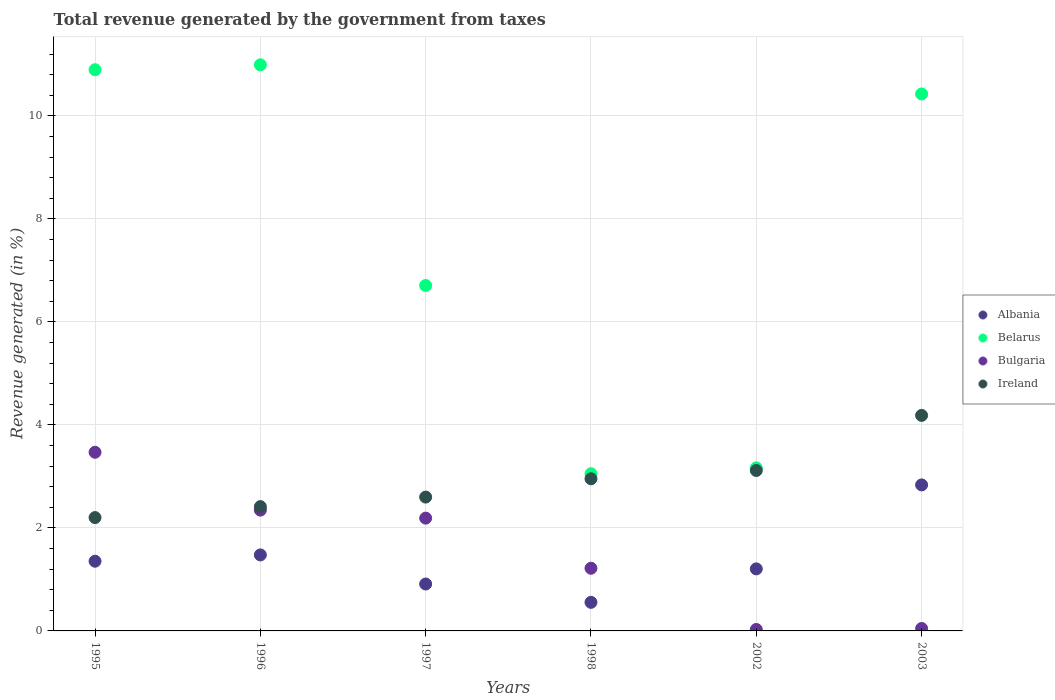Is the number of dotlines equal to the number of legend labels?
Keep it short and to the point. Yes. What is the total revenue generated in Bulgaria in 1996?
Your answer should be very brief. 2.35. Across all years, what is the maximum total revenue generated in Ireland?
Provide a succinct answer. 4.18. Across all years, what is the minimum total revenue generated in Belarus?
Ensure brevity in your answer.  3.05. What is the total total revenue generated in Ireland in the graph?
Your answer should be very brief. 17.47. What is the difference between the total revenue generated in Bulgaria in 1996 and that in 1998?
Provide a short and direct response. 1.13. What is the difference between the total revenue generated in Ireland in 2003 and the total revenue generated in Bulgaria in 1995?
Your answer should be compact. 0.72. What is the average total revenue generated in Ireland per year?
Offer a very short reply. 2.91. In the year 2002, what is the difference between the total revenue generated in Ireland and total revenue generated in Belarus?
Provide a short and direct response. -0.05. What is the ratio of the total revenue generated in Bulgaria in 1996 to that in 1998?
Give a very brief answer. 1.93. Is the total revenue generated in Belarus in 1996 less than that in 1997?
Your response must be concise. No. Is the difference between the total revenue generated in Ireland in 1997 and 2003 greater than the difference between the total revenue generated in Belarus in 1997 and 2003?
Ensure brevity in your answer.  Yes. What is the difference between the highest and the second highest total revenue generated in Ireland?
Your response must be concise. 1.07. What is the difference between the highest and the lowest total revenue generated in Belarus?
Provide a short and direct response. 7.94. Is the sum of the total revenue generated in Albania in 1998 and 2003 greater than the maximum total revenue generated in Ireland across all years?
Give a very brief answer. No. Is it the case that in every year, the sum of the total revenue generated in Albania and total revenue generated in Ireland  is greater than the sum of total revenue generated in Belarus and total revenue generated in Bulgaria?
Provide a short and direct response. No. Is it the case that in every year, the sum of the total revenue generated in Belarus and total revenue generated in Ireland  is greater than the total revenue generated in Bulgaria?
Your response must be concise. Yes. Does the total revenue generated in Albania monotonically increase over the years?
Offer a terse response. No. Is the total revenue generated in Bulgaria strictly greater than the total revenue generated in Ireland over the years?
Offer a terse response. No. Does the graph contain any zero values?
Offer a very short reply. No. Does the graph contain grids?
Your response must be concise. Yes. Where does the legend appear in the graph?
Provide a short and direct response. Center right. What is the title of the graph?
Give a very brief answer. Total revenue generated by the government from taxes. Does "Middle East & North Africa (all income levels)" appear as one of the legend labels in the graph?
Give a very brief answer. No. What is the label or title of the X-axis?
Your response must be concise. Years. What is the label or title of the Y-axis?
Make the answer very short. Revenue generated (in %). What is the Revenue generated (in %) of Albania in 1995?
Make the answer very short. 1.35. What is the Revenue generated (in %) in Belarus in 1995?
Make the answer very short. 10.9. What is the Revenue generated (in %) of Bulgaria in 1995?
Provide a succinct answer. 3.47. What is the Revenue generated (in %) in Ireland in 1995?
Provide a short and direct response. 2.2. What is the Revenue generated (in %) in Albania in 1996?
Your answer should be compact. 1.48. What is the Revenue generated (in %) of Belarus in 1996?
Give a very brief answer. 10.99. What is the Revenue generated (in %) of Bulgaria in 1996?
Your response must be concise. 2.35. What is the Revenue generated (in %) in Ireland in 1996?
Offer a terse response. 2.41. What is the Revenue generated (in %) of Albania in 1997?
Keep it short and to the point. 0.91. What is the Revenue generated (in %) in Belarus in 1997?
Provide a succinct answer. 6.71. What is the Revenue generated (in %) of Bulgaria in 1997?
Your response must be concise. 2.19. What is the Revenue generated (in %) of Ireland in 1997?
Your answer should be compact. 2.6. What is the Revenue generated (in %) of Albania in 1998?
Make the answer very short. 0.55. What is the Revenue generated (in %) in Belarus in 1998?
Give a very brief answer. 3.05. What is the Revenue generated (in %) in Bulgaria in 1998?
Provide a succinct answer. 1.22. What is the Revenue generated (in %) in Ireland in 1998?
Provide a succinct answer. 2.95. What is the Revenue generated (in %) of Albania in 2002?
Offer a terse response. 1.2. What is the Revenue generated (in %) of Belarus in 2002?
Ensure brevity in your answer.  3.17. What is the Revenue generated (in %) in Bulgaria in 2002?
Provide a succinct answer. 0.03. What is the Revenue generated (in %) in Ireland in 2002?
Make the answer very short. 3.11. What is the Revenue generated (in %) in Albania in 2003?
Your response must be concise. 2.83. What is the Revenue generated (in %) of Belarus in 2003?
Offer a very short reply. 10.43. What is the Revenue generated (in %) of Bulgaria in 2003?
Give a very brief answer. 0.05. What is the Revenue generated (in %) in Ireland in 2003?
Your response must be concise. 4.18. Across all years, what is the maximum Revenue generated (in %) in Albania?
Your answer should be compact. 2.83. Across all years, what is the maximum Revenue generated (in %) of Belarus?
Your response must be concise. 10.99. Across all years, what is the maximum Revenue generated (in %) of Bulgaria?
Offer a very short reply. 3.47. Across all years, what is the maximum Revenue generated (in %) of Ireland?
Your response must be concise. 4.18. Across all years, what is the minimum Revenue generated (in %) in Albania?
Offer a terse response. 0.55. Across all years, what is the minimum Revenue generated (in %) of Belarus?
Offer a very short reply. 3.05. Across all years, what is the minimum Revenue generated (in %) of Bulgaria?
Ensure brevity in your answer.  0.03. Across all years, what is the minimum Revenue generated (in %) in Ireland?
Provide a succinct answer. 2.2. What is the total Revenue generated (in %) of Albania in the graph?
Make the answer very short. 8.33. What is the total Revenue generated (in %) in Belarus in the graph?
Give a very brief answer. 45.24. What is the total Revenue generated (in %) in Bulgaria in the graph?
Offer a terse response. 9.3. What is the total Revenue generated (in %) in Ireland in the graph?
Keep it short and to the point. 17.47. What is the difference between the Revenue generated (in %) of Albania in 1995 and that in 1996?
Your answer should be very brief. -0.12. What is the difference between the Revenue generated (in %) in Belarus in 1995 and that in 1996?
Your answer should be compact. -0.1. What is the difference between the Revenue generated (in %) in Bulgaria in 1995 and that in 1996?
Make the answer very short. 1.12. What is the difference between the Revenue generated (in %) of Ireland in 1995 and that in 1996?
Your answer should be very brief. -0.21. What is the difference between the Revenue generated (in %) in Albania in 1995 and that in 1997?
Ensure brevity in your answer.  0.44. What is the difference between the Revenue generated (in %) of Belarus in 1995 and that in 1997?
Your answer should be compact. 4.19. What is the difference between the Revenue generated (in %) in Bulgaria in 1995 and that in 1997?
Your answer should be very brief. 1.28. What is the difference between the Revenue generated (in %) of Ireland in 1995 and that in 1997?
Make the answer very short. -0.4. What is the difference between the Revenue generated (in %) of Albania in 1995 and that in 1998?
Your response must be concise. 0.8. What is the difference between the Revenue generated (in %) in Belarus in 1995 and that in 1998?
Give a very brief answer. 7.84. What is the difference between the Revenue generated (in %) in Bulgaria in 1995 and that in 1998?
Provide a short and direct response. 2.25. What is the difference between the Revenue generated (in %) of Ireland in 1995 and that in 1998?
Ensure brevity in your answer.  -0.75. What is the difference between the Revenue generated (in %) in Albania in 1995 and that in 2002?
Provide a succinct answer. 0.15. What is the difference between the Revenue generated (in %) in Belarus in 1995 and that in 2002?
Offer a terse response. 7.73. What is the difference between the Revenue generated (in %) in Bulgaria in 1995 and that in 2002?
Your answer should be very brief. 3.44. What is the difference between the Revenue generated (in %) of Ireland in 1995 and that in 2002?
Provide a succinct answer. -0.91. What is the difference between the Revenue generated (in %) of Albania in 1995 and that in 2003?
Ensure brevity in your answer.  -1.48. What is the difference between the Revenue generated (in %) in Belarus in 1995 and that in 2003?
Your answer should be compact. 0.47. What is the difference between the Revenue generated (in %) of Bulgaria in 1995 and that in 2003?
Keep it short and to the point. 3.42. What is the difference between the Revenue generated (in %) in Ireland in 1995 and that in 2003?
Provide a short and direct response. -1.98. What is the difference between the Revenue generated (in %) in Albania in 1996 and that in 1997?
Make the answer very short. 0.56. What is the difference between the Revenue generated (in %) in Belarus in 1996 and that in 1997?
Provide a short and direct response. 4.28. What is the difference between the Revenue generated (in %) in Bulgaria in 1996 and that in 1997?
Your response must be concise. 0.16. What is the difference between the Revenue generated (in %) in Ireland in 1996 and that in 1997?
Provide a short and direct response. -0.19. What is the difference between the Revenue generated (in %) of Albania in 1996 and that in 1998?
Your answer should be compact. 0.92. What is the difference between the Revenue generated (in %) of Belarus in 1996 and that in 1998?
Ensure brevity in your answer.  7.94. What is the difference between the Revenue generated (in %) in Bulgaria in 1996 and that in 1998?
Your response must be concise. 1.13. What is the difference between the Revenue generated (in %) in Ireland in 1996 and that in 1998?
Your response must be concise. -0.54. What is the difference between the Revenue generated (in %) of Albania in 1996 and that in 2002?
Keep it short and to the point. 0.27. What is the difference between the Revenue generated (in %) in Belarus in 1996 and that in 2002?
Offer a terse response. 7.83. What is the difference between the Revenue generated (in %) of Bulgaria in 1996 and that in 2002?
Provide a short and direct response. 2.32. What is the difference between the Revenue generated (in %) in Ireland in 1996 and that in 2002?
Your answer should be very brief. -0.7. What is the difference between the Revenue generated (in %) in Albania in 1996 and that in 2003?
Give a very brief answer. -1.36. What is the difference between the Revenue generated (in %) of Belarus in 1996 and that in 2003?
Keep it short and to the point. 0.57. What is the difference between the Revenue generated (in %) of Bulgaria in 1996 and that in 2003?
Ensure brevity in your answer.  2.3. What is the difference between the Revenue generated (in %) of Ireland in 1996 and that in 2003?
Provide a short and direct response. -1.77. What is the difference between the Revenue generated (in %) in Albania in 1997 and that in 1998?
Provide a succinct answer. 0.36. What is the difference between the Revenue generated (in %) in Belarus in 1997 and that in 1998?
Make the answer very short. 3.65. What is the difference between the Revenue generated (in %) in Ireland in 1997 and that in 1998?
Make the answer very short. -0.36. What is the difference between the Revenue generated (in %) in Albania in 1997 and that in 2002?
Offer a very short reply. -0.29. What is the difference between the Revenue generated (in %) of Belarus in 1997 and that in 2002?
Make the answer very short. 3.54. What is the difference between the Revenue generated (in %) in Bulgaria in 1997 and that in 2002?
Your answer should be very brief. 2.16. What is the difference between the Revenue generated (in %) in Ireland in 1997 and that in 2002?
Make the answer very short. -0.52. What is the difference between the Revenue generated (in %) of Albania in 1997 and that in 2003?
Your response must be concise. -1.92. What is the difference between the Revenue generated (in %) in Belarus in 1997 and that in 2003?
Ensure brevity in your answer.  -3.72. What is the difference between the Revenue generated (in %) of Bulgaria in 1997 and that in 2003?
Offer a terse response. 2.14. What is the difference between the Revenue generated (in %) in Ireland in 1997 and that in 2003?
Offer a terse response. -1.59. What is the difference between the Revenue generated (in %) in Albania in 1998 and that in 2002?
Provide a succinct answer. -0.65. What is the difference between the Revenue generated (in %) in Belarus in 1998 and that in 2002?
Provide a succinct answer. -0.11. What is the difference between the Revenue generated (in %) in Bulgaria in 1998 and that in 2002?
Provide a succinct answer. 1.19. What is the difference between the Revenue generated (in %) in Ireland in 1998 and that in 2002?
Your response must be concise. -0.16. What is the difference between the Revenue generated (in %) of Albania in 1998 and that in 2003?
Your answer should be very brief. -2.28. What is the difference between the Revenue generated (in %) of Belarus in 1998 and that in 2003?
Your answer should be compact. -7.37. What is the difference between the Revenue generated (in %) in Bulgaria in 1998 and that in 2003?
Give a very brief answer. 1.17. What is the difference between the Revenue generated (in %) of Ireland in 1998 and that in 2003?
Give a very brief answer. -1.23. What is the difference between the Revenue generated (in %) of Albania in 2002 and that in 2003?
Give a very brief answer. -1.63. What is the difference between the Revenue generated (in %) in Belarus in 2002 and that in 2003?
Offer a very short reply. -7.26. What is the difference between the Revenue generated (in %) in Bulgaria in 2002 and that in 2003?
Provide a short and direct response. -0.02. What is the difference between the Revenue generated (in %) of Ireland in 2002 and that in 2003?
Ensure brevity in your answer.  -1.07. What is the difference between the Revenue generated (in %) in Albania in 1995 and the Revenue generated (in %) in Belarus in 1996?
Your response must be concise. -9.64. What is the difference between the Revenue generated (in %) of Albania in 1995 and the Revenue generated (in %) of Bulgaria in 1996?
Provide a succinct answer. -0.99. What is the difference between the Revenue generated (in %) of Albania in 1995 and the Revenue generated (in %) of Ireland in 1996?
Ensure brevity in your answer.  -1.06. What is the difference between the Revenue generated (in %) of Belarus in 1995 and the Revenue generated (in %) of Bulgaria in 1996?
Ensure brevity in your answer.  8.55. What is the difference between the Revenue generated (in %) in Belarus in 1995 and the Revenue generated (in %) in Ireland in 1996?
Offer a terse response. 8.48. What is the difference between the Revenue generated (in %) of Bulgaria in 1995 and the Revenue generated (in %) of Ireland in 1996?
Offer a terse response. 1.06. What is the difference between the Revenue generated (in %) in Albania in 1995 and the Revenue generated (in %) in Belarus in 1997?
Keep it short and to the point. -5.35. What is the difference between the Revenue generated (in %) in Albania in 1995 and the Revenue generated (in %) in Bulgaria in 1997?
Offer a very short reply. -0.84. What is the difference between the Revenue generated (in %) in Albania in 1995 and the Revenue generated (in %) in Ireland in 1997?
Keep it short and to the point. -1.25. What is the difference between the Revenue generated (in %) of Belarus in 1995 and the Revenue generated (in %) of Bulgaria in 1997?
Keep it short and to the point. 8.71. What is the difference between the Revenue generated (in %) of Belarus in 1995 and the Revenue generated (in %) of Ireland in 1997?
Your answer should be compact. 8.3. What is the difference between the Revenue generated (in %) in Bulgaria in 1995 and the Revenue generated (in %) in Ireland in 1997?
Keep it short and to the point. 0.87. What is the difference between the Revenue generated (in %) of Albania in 1995 and the Revenue generated (in %) of Belarus in 1998?
Keep it short and to the point. -1.7. What is the difference between the Revenue generated (in %) of Albania in 1995 and the Revenue generated (in %) of Bulgaria in 1998?
Your response must be concise. 0.14. What is the difference between the Revenue generated (in %) in Albania in 1995 and the Revenue generated (in %) in Ireland in 1998?
Ensure brevity in your answer.  -1.6. What is the difference between the Revenue generated (in %) in Belarus in 1995 and the Revenue generated (in %) in Bulgaria in 1998?
Offer a terse response. 9.68. What is the difference between the Revenue generated (in %) of Belarus in 1995 and the Revenue generated (in %) of Ireland in 1998?
Offer a terse response. 7.94. What is the difference between the Revenue generated (in %) of Bulgaria in 1995 and the Revenue generated (in %) of Ireland in 1998?
Your answer should be compact. 0.51. What is the difference between the Revenue generated (in %) of Albania in 1995 and the Revenue generated (in %) of Belarus in 2002?
Provide a short and direct response. -1.81. What is the difference between the Revenue generated (in %) in Albania in 1995 and the Revenue generated (in %) in Bulgaria in 2002?
Your response must be concise. 1.33. What is the difference between the Revenue generated (in %) in Albania in 1995 and the Revenue generated (in %) in Ireland in 2002?
Keep it short and to the point. -1.76. What is the difference between the Revenue generated (in %) of Belarus in 1995 and the Revenue generated (in %) of Bulgaria in 2002?
Make the answer very short. 10.87. What is the difference between the Revenue generated (in %) in Belarus in 1995 and the Revenue generated (in %) in Ireland in 2002?
Your answer should be compact. 7.78. What is the difference between the Revenue generated (in %) of Bulgaria in 1995 and the Revenue generated (in %) of Ireland in 2002?
Give a very brief answer. 0.35. What is the difference between the Revenue generated (in %) in Albania in 1995 and the Revenue generated (in %) in Belarus in 2003?
Give a very brief answer. -9.07. What is the difference between the Revenue generated (in %) in Albania in 1995 and the Revenue generated (in %) in Bulgaria in 2003?
Make the answer very short. 1.31. What is the difference between the Revenue generated (in %) of Albania in 1995 and the Revenue generated (in %) of Ireland in 2003?
Your answer should be very brief. -2.83. What is the difference between the Revenue generated (in %) in Belarus in 1995 and the Revenue generated (in %) in Bulgaria in 2003?
Keep it short and to the point. 10.85. What is the difference between the Revenue generated (in %) in Belarus in 1995 and the Revenue generated (in %) in Ireland in 2003?
Provide a short and direct response. 6.71. What is the difference between the Revenue generated (in %) in Bulgaria in 1995 and the Revenue generated (in %) in Ireland in 2003?
Keep it short and to the point. -0.72. What is the difference between the Revenue generated (in %) of Albania in 1996 and the Revenue generated (in %) of Belarus in 1997?
Offer a terse response. -5.23. What is the difference between the Revenue generated (in %) of Albania in 1996 and the Revenue generated (in %) of Bulgaria in 1997?
Ensure brevity in your answer.  -0.71. What is the difference between the Revenue generated (in %) in Albania in 1996 and the Revenue generated (in %) in Ireland in 1997?
Give a very brief answer. -1.12. What is the difference between the Revenue generated (in %) of Belarus in 1996 and the Revenue generated (in %) of Bulgaria in 1997?
Your response must be concise. 8.8. What is the difference between the Revenue generated (in %) of Belarus in 1996 and the Revenue generated (in %) of Ireland in 1997?
Your answer should be compact. 8.39. What is the difference between the Revenue generated (in %) in Bulgaria in 1996 and the Revenue generated (in %) in Ireland in 1997?
Keep it short and to the point. -0.25. What is the difference between the Revenue generated (in %) in Albania in 1996 and the Revenue generated (in %) in Belarus in 1998?
Ensure brevity in your answer.  -1.58. What is the difference between the Revenue generated (in %) of Albania in 1996 and the Revenue generated (in %) of Bulgaria in 1998?
Keep it short and to the point. 0.26. What is the difference between the Revenue generated (in %) of Albania in 1996 and the Revenue generated (in %) of Ireland in 1998?
Your answer should be compact. -1.48. What is the difference between the Revenue generated (in %) of Belarus in 1996 and the Revenue generated (in %) of Bulgaria in 1998?
Provide a succinct answer. 9.77. What is the difference between the Revenue generated (in %) of Belarus in 1996 and the Revenue generated (in %) of Ireland in 1998?
Give a very brief answer. 8.04. What is the difference between the Revenue generated (in %) of Bulgaria in 1996 and the Revenue generated (in %) of Ireland in 1998?
Offer a very short reply. -0.61. What is the difference between the Revenue generated (in %) in Albania in 1996 and the Revenue generated (in %) in Belarus in 2002?
Give a very brief answer. -1.69. What is the difference between the Revenue generated (in %) in Albania in 1996 and the Revenue generated (in %) in Bulgaria in 2002?
Your answer should be compact. 1.45. What is the difference between the Revenue generated (in %) in Albania in 1996 and the Revenue generated (in %) in Ireland in 2002?
Make the answer very short. -1.64. What is the difference between the Revenue generated (in %) of Belarus in 1996 and the Revenue generated (in %) of Bulgaria in 2002?
Give a very brief answer. 10.96. What is the difference between the Revenue generated (in %) in Belarus in 1996 and the Revenue generated (in %) in Ireland in 2002?
Provide a short and direct response. 7.88. What is the difference between the Revenue generated (in %) in Bulgaria in 1996 and the Revenue generated (in %) in Ireland in 2002?
Keep it short and to the point. -0.77. What is the difference between the Revenue generated (in %) of Albania in 1996 and the Revenue generated (in %) of Belarus in 2003?
Provide a short and direct response. -8.95. What is the difference between the Revenue generated (in %) of Albania in 1996 and the Revenue generated (in %) of Bulgaria in 2003?
Your answer should be compact. 1.43. What is the difference between the Revenue generated (in %) of Albania in 1996 and the Revenue generated (in %) of Ireland in 2003?
Your answer should be very brief. -2.71. What is the difference between the Revenue generated (in %) in Belarus in 1996 and the Revenue generated (in %) in Bulgaria in 2003?
Your response must be concise. 10.94. What is the difference between the Revenue generated (in %) of Belarus in 1996 and the Revenue generated (in %) of Ireland in 2003?
Keep it short and to the point. 6.81. What is the difference between the Revenue generated (in %) of Bulgaria in 1996 and the Revenue generated (in %) of Ireland in 2003?
Offer a terse response. -1.84. What is the difference between the Revenue generated (in %) of Albania in 1997 and the Revenue generated (in %) of Belarus in 1998?
Offer a very short reply. -2.14. What is the difference between the Revenue generated (in %) of Albania in 1997 and the Revenue generated (in %) of Bulgaria in 1998?
Your answer should be very brief. -0.31. What is the difference between the Revenue generated (in %) of Albania in 1997 and the Revenue generated (in %) of Ireland in 1998?
Keep it short and to the point. -2.04. What is the difference between the Revenue generated (in %) in Belarus in 1997 and the Revenue generated (in %) in Bulgaria in 1998?
Make the answer very short. 5.49. What is the difference between the Revenue generated (in %) of Belarus in 1997 and the Revenue generated (in %) of Ireland in 1998?
Offer a terse response. 3.75. What is the difference between the Revenue generated (in %) of Bulgaria in 1997 and the Revenue generated (in %) of Ireland in 1998?
Your response must be concise. -0.76. What is the difference between the Revenue generated (in %) in Albania in 1997 and the Revenue generated (in %) in Belarus in 2002?
Give a very brief answer. -2.25. What is the difference between the Revenue generated (in %) in Albania in 1997 and the Revenue generated (in %) in Bulgaria in 2002?
Your response must be concise. 0.88. What is the difference between the Revenue generated (in %) of Albania in 1997 and the Revenue generated (in %) of Ireland in 2002?
Offer a terse response. -2.2. What is the difference between the Revenue generated (in %) in Belarus in 1997 and the Revenue generated (in %) in Bulgaria in 2002?
Ensure brevity in your answer.  6.68. What is the difference between the Revenue generated (in %) in Belarus in 1997 and the Revenue generated (in %) in Ireland in 2002?
Offer a very short reply. 3.59. What is the difference between the Revenue generated (in %) in Bulgaria in 1997 and the Revenue generated (in %) in Ireland in 2002?
Provide a short and direct response. -0.93. What is the difference between the Revenue generated (in %) of Albania in 1997 and the Revenue generated (in %) of Belarus in 2003?
Make the answer very short. -9.51. What is the difference between the Revenue generated (in %) of Albania in 1997 and the Revenue generated (in %) of Bulgaria in 2003?
Offer a terse response. 0.86. What is the difference between the Revenue generated (in %) in Albania in 1997 and the Revenue generated (in %) in Ireland in 2003?
Your response must be concise. -3.27. What is the difference between the Revenue generated (in %) in Belarus in 1997 and the Revenue generated (in %) in Bulgaria in 2003?
Provide a short and direct response. 6.66. What is the difference between the Revenue generated (in %) of Belarus in 1997 and the Revenue generated (in %) of Ireland in 2003?
Make the answer very short. 2.52. What is the difference between the Revenue generated (in %) of Bulgaria in 1997 and the Revenue generated (in %) of Ireland in 2003?
Provide a succinct answer. -1.99. What is the difference between the Revenue generated (in %) of Albania in 1998 and the Revenue generated (in %) of Belarus in 2002?
Your answer should be very brief. -2.61. What is the difference between the Revenue generated (in %) in Albania in 1998 and the Revenue generated (in %) in Bulgaria in 2002?
Give a very brief answer. 0.53. What is the difference between the Revenue generated (in %) in Albania in 1998 and the Revenue generated (in %) in Ireland in 2002?
Keep it short and to the point. -2.56. What is the difference between the Revenue generated (in %) of Belarus in 1998 and the Revenue generated (in %) of Bulgaria in 2002?
Give a very brief answer. 3.02. What is the difference between the Revenue generated (in %) of Belarus in 1998 and the Revenue generated (in %) of Ireland in 2002?
Provide a short and direct response. -0.06. What is the difference between the Revenue generated (in %) of Bulgaria in 1998 and the Revenue generated (in %) of Ireland in 2002?
Provide a short and direct response. -1.9. What is the difference between the Revenue generated (in %) of Albania in 1998 and the Revenue generated (in %) of Belarus in 2003?
Your answer should be compact. -9.87. What is the difference between the Revenue generated (in %) of Albania in 1998 and the Revenue generated (in %) of Bulgaria in 2003?
Provide a succinct answer. 0.51. What is the difference between the Revenue generated (in %) in Albania in 1998 and the Revenue generated (in %) in Ireland in 2003?
Provide a succinct answer. -3.63. What is the difference between the Revenue generated (in %) in Belarus in 1998 and the Revenue generated (in %) in Bulgaria in 2003?
Your answer should be compact. 3. What is the difference between the Revenue generated (in %) in Belarus in 1998 and the Revenue generated (in %) in Ireland in 2003?
Your answer should be compact. -1.13. What is the difference between the Revenue generated (in %) in Bulgaria in 1998 and the Revenue generated (in %) in Ireland in 2003?
Ensure brevity in your answer.  -2.97. What is the difference between the Revenue generated (in %) of Albania in 2002 and the Revenue generated (in %) of Belarus in 2003?
Offer a very short reply. -9.22. What is the difference between the Revenue generated (in %) in Albania in 2002 and the Revenue generated (in %) in Bulgaria in 2003?
Your answer should be very brief. 1.16. What is the difference between the Revenue generated (in %) of Albania in 2002 and the Revenue generated (in %) of Ireland in 2003?
Provide a short and direct response. -2.98. What is the difference between the Revenue generated (in %) in Belarus in 2002 and the Revenue generated (in %) in Bulgaria in 2003?
Provide a succinct answer. 3.12. What is the difference between the Revenue generated (in %) of Belarus in 2002 and the Revenue generated (in %) of Ireland in 2003?
Offer a terse response. -1.02. What is the difference between the Revenue generated (in %) of Bulgaria in 2002 and the Revenue generated (in %) of Ireland in 2003?
Give a very brief answer. -4.16. What is the average Revenue generated (in %) of Albania per year?
Ensure brevity in your answer.  1.39. What is the average Revenue generated (in %) of Belarus per year?
Your answer should be compact. 7.54. What is the average Revenue generated (in %) in Bulgaria per year?
Give a very brief answer. 1.55. What is the average Revenue generated (in %) in Ireland per year?
Offer a terse response. 2.91. In the year 1995, what is the difference between the Revenue generated (in %) in Albania and Revenue generated (in %) in Belarus?
Give a very brief answer. -9.54. In the year 1995, what is the difference between the Revenue generated (in %) of Albania and Revenue generated (in %) of Bulgaria?
Offer a terse response. -2.12. In the year 1995, what is the difference between the Revenue generated (in %) of Albania and Revenue generated (in %) of Ireland?
Offer a very short reply. -0.85. In the year 1995, what is the difference between the Revenue generated (in %) of Belarus and Revenue generated (in %) of Bulgaria?
Ensure brevity in your answer.  7.43. In the year 1995, what is the difference between the Revenue generated (in %) of Belarus and Revenue generated (in %) of Ireland?
Your answer should be compact. 8.7. In the year 1995, what is the difference between the Revenue generated (in %) in Bulgaria and Revenue generated (in %) in Ireland?
Provide a short and direct response. 1.27. In the year 1996, what is the difference between the Revenue generated (in %) of Albania and Revenue generated (in %) of Belarus?
Offer a very short reply. -9.52. In the year 1996, what is the difference between the Revenue generated (in %) in Albania and Revenue generated (in %) in Bulgaria?
Make the answer very short. -0.87. In the year 1996, what is the difference between the Revenue generated (in %) of Albania and Revenue generated (in %) of Ireland?
Your answer should be compact. -0.94. In the year 1996, what is the difference between the Revenue generated (in %) in Belarus and Revenue generated (in %) in Bulgaria?
Offer a terse response. 8.65. In the year 1996, what is the difference between the Revenue generated (in %) in Belarus and Revenue generated (in %) in Ireland?
Your answer should be very brief. 8.58. In the year 1996, what is the difference between the Revenue generated (in %) of Bulgaria and Revenue generated (in %) of Ireland?
Give a very brief answer. -0.07. In the year 1997, what is the difference between the Revenue generated (in %) in Albania and Revenue generated (in %) in Belarus?
Provide a short and direct response. -5.8. In the year 1997, what is the difference between the Revenue generated (in %) of Albania and Revenue generated (in %) of Bulgaria?
Make the answer very short. -1.28. In the year 1997, what is the difference between the Revenue generated (in %) of Albania and Revenue generated (in %) of Ireland?
Offer a very short reply. -1.69. In the year 1997, what is the difference between the Revenue generated (in %) of Belarus and Revenue generated (in %) of Bulgaria?
Your response must be concise. 4.52. In the year 1997, what is the difference between the Revenue generated (in %) of Belarus and Revenue generated (in %) of Ireland?
Provide a short and direct response. 4.11. In the year 1997, what is the difference between the Revenue generated (in %) of Bulgaria and Revenue generated (in %) of Ireland?
Your answer should be compact. -0.41. In the year 1998, what is the difference between the Revenue generated (in %) of Albania and Revenue generated (in %) of Belarus?
Your answer should be very brief. -2.5. In the year 1998, what is the difference between the Revenue generated (in %) in Albania and Revenue generated (in %) in Bulgaria?
Provide a succinct answer. -0.66. In the year 1998, what is the difference between the Revenue generated (in %) of Albania and Revenue generated (in %) of Ireland?
Offer a very short reply. -2.4. In the year 1998, what is the difference between the Revenue generated (in %) in Belarus and Revenue generated (in %) in Bulgaria?
Offer a terse response. 1.84. In the year 1998, what is the difference between the Revenue generated (in %) in Belarus and Revenue generated (in %) in Ireland?
Ensure brevity in your answer.  0.1. In the year 1998, what is the difference between the Revenue generated (in %) of Bulgaria and Revenue generated (in %) of Ireland?
Ensure brevity in your answer.  -1.74. In the year 2002, what is the difference between the Revenue generated (in %) of Albania and Revenue generated (in %) of Belarus?
Your answer should be very brief. -1.96. In the year 2002, what is the difference between the Revenue generated (in %) in Albania and Revenue generated (in %) in Bulgaria?
Your response must be concise. 1.18. In the year 2002, what is the difference between the Revenue generated (in %) of Albania and Revenue generated (in %) of Ireland?
Make the answer very short. -1.91. In the year 2002, what is the difference between the Revenue generated (in %) in Belarus and Revenue generated (in %) in Bulgaria?
Your response must be concise. 3.14. In the year 2002, what is the difference between the Revenue generated (in %) in Belarus and Revenue generated (in %) in Ireland?
Ensure brevity in your answer.  0.05. In the year 2002, what is the difference between the Revenue generated (in %) of Bulgaria and Revenue generated (in %) of Ireland?
Make the answer very short. -3.09. In the year 2003, what is the difference between the Revenue generated (in %) in Albania and Revenue generated (in %) in Belarus?
Your answer should be compact. -7.59. In the year 2003, what is the difference between the Revenue generated (in %) of Albania and Revenue generated (in %) of Bulgaria?
Keep it short and to the point. 2.79. In the year 2003, what is the difference between the Revenue generated (in %) in Albania and Revenue generated (in %) in Ireland?
Make the answer very short. -1.35. In the year 2003, what is the difference between the Revenue generated (in %) of Belarus and Revenue generated (in %) of Bulgaria?
Provide a succinct answer. 10.38. In the year 2003, what is the difference between the Revenue generated (in %) of Belarus and Revenue generated (in %) of Ireland?
Offer a terse response. 6.24. In the year 2003, what is the difference between the Revenue generated (in %) of Bulgaria and Revenue generated (in %) of Ireland?
Provide a succinct answer. -4.14. What is the ratio of the Revenue generated (in %) of Albania in 1995 to that in 1996?
Offer a terse response. 0.92. What is the ratio of the Revenue generated (in %) of Belarus in 1995 to that in 1996?
Provide a short and direct response. 0.99. What is the ratio of the Revenue generated (in %) of Bulgaria in 1995 to that in 1996?
Make the answer very short. 1.48. What is the ratio of the Revenue generated (in %) in Ireland in 1995 to that in 1996?
Offer a terse response. 0.91. What is the ratio of the Revenue generated (in %) in Albania in 1995 to that in 1997?
Offer a very short reply. 1.49. What is the ratio of the Revenue generated (in %) in Belarus in 1995 to that in 1997?
Give a very brief answer. 1.62. What is the ratio of the Revenue generated (in %) in Bulgaria in 1995 to that in 1997?
Give a very brief answer. 1.58. What is the ratio of the Revenue generated (in %) in Ireland in 1995 to that in 1997?
Give a very brief answer. 0.85. What is the ratio of the Revenue generated (in %) of Albania in 1995 to that in 1998?
Make the answer very short. 2.44. What is the ratio of the Revenue generated (in %) in Belarus in 1995 to that in 1998?
Provide a succinct answer. 3.57. What is the ratio of the Revenue generated (in %) of Bulgaria in 1995 to that in 1998?
Your response must be concise. 2.85. What is the ratio of the Revenue generated (in %) of Ireland in 1995 to that in 1998?
Provide a short and direct response. 0.74. What is the ratio of the Revenue generated (in %) in Albania in 1995 to that in 2002?
Provide a short and direct response. 1.12. What is the ratio of the Revenue generated (in %) of Belarus in 1995 to that in 2002?
Your response must be concise. 3.44. What is the ratio of the Revenue generated (in %) of Bulgaria in 1995 to that in 2002?
Your response must be concise. 123.51. What is the ratio of the Revenue generated (in %) of Ireland in 1995 to that in 2002?
Your answer should be very brief. 0.71. What is the ratio of the Revenue generated (in %) of Albania in 1995 to that in 2003?
Provide a succinct answer. 0.48. What is the ratio of the Revenue generated (in %) in Belarus in 1995 to that in 2003?
Give a very brief answer. 1.05. What is the ratio of the Revenue generated (in %) in Bulgaria in 1995 to that in 2003?
Offer a very short reply. 73.05. What is the ratio of the Revenue generated (in %) of Ireland in 1995 to that in 2003?
Ensure brevity in your answer.  0.53. What is the ratio of the Revenue generated (in %) in Albania in 1996 to that in 1997?
Offer a terse response. 1.62. What is the ratio of the Revenue generated (in %) of Belarus in 1996 to that in 1997?
Your answer should be very brief. 1.64. What is the ratio of the Revenue generated (in %) of Bulgaria in 1996 to that in 1997?
Offer a very short reply. 1.07. What is the ratio of the Revenue generated (in %) of Ireland in 1996 to that in 1997?
Offer a very short reply. 0.93. What is the ratio of the Revenue generated (in %) in Albania in 1996 to that in 1998?
Give a very brief answer. 2.66. What is the ratio of the Revenue generated (in %) of Belarus in 1996 to that in 1998?
Keep it short and to the point. 3.6. What is the ratio of the Revenue generated (in %) in Bulgaria in 1996 to that in 1998?
Keep it short and to the point. 1.93. What is the ratio of the Revenue generated (in %) of Ireland in 1996 to that in 1998?
Your answer should be very brief. 0.82. What is the ratio of the Revenue generated (in %) of Albania in 1996 to that in 2002?
Give a very brief answer. 1.23. What is the ratio of the Revenue generated (in %) of Belarus in 1996 to that in 2002?
Make the answer very short. 3.47. What is the ratio of the Revenue generated (in %) in Bulgaria in 1996 to that in 2002?
Your answer should be very brief. 83.51. What is the ratio of the Revenue generated (in %) in Ireland in 1996 to that in 2002?
Ensure brevity in your answer.  0.77. What is the ratio of the Revenue generated (in %) in Albania in 1996 to that in 2003?
Provide a succinct answer. 0.52. What is the ratio of the Revenue generated (in %) of Belarus in 1996 to that in 2003?
Provide a short and direct response. 1.05. What is the ratio of the Revenue generated (in %) of Bulgaria in 1996 to that in 2003?
Make the answer very short. 49.39. What is the ratio of the Revenue generated (in %) of Ireland in 1996 to that in 2003?
Give a very brief answer. 0.58. What is the ratio of the Revenue generated (in %) in Albania in 1997 to that in 1998?
Give a very brief answer. 1.64. What is the ratio of the Revenue generated (in %) of Belarus in 1997 to that in 1998?
Provide a succinct answer. 2.2. What is the ratio of the Revenue generated (in %) of Bulgaria in 1997 to that in 1998?
Your answer should be very brief. 1.8. What is the ratio of the Revenue generated (in %) of Ireland in 1997 to that in 1998?
Keep it short and to the point. 0.88. What is the ratio of the Revenue generated (in %) in Albania in 1997 to that in 2002?
Give a very brief answer. 0.76. What is the ratio of the Revenue generated (in %) in Belarus in 1997 to that in 2002?
Keep it short and to the point. 2.12. What is the ratio of the Revenue generated (in %) in Bulgaria in 1997 to that in 2002?
Provide a succinct answer. 77.97. What is the ratio of the Revenue generated (in %) in Ireland in 1997 to that in 2002?
Ensure brevity in your answer.  0.83. What is the ratio of the Revenue generated (in %) in Albania in 1997 to that in 2003?
Provide a short and direct response. 0.32. What is the ratio of the Revenue generated (in %) in Belarus in 1997 to that in 2003?
Your answer should be very brief. 0.64. What is the ratio of the Revenue generated (in %) in Bulgaria in 1997 to that in 2003?
Keep it short and to the point. 46.12. What is the ratio of the Revenue generated (in %) in Ireland in 1997 to that in 2003?
Give a very brief answer. 0.62. What is the ratio of the Revenue generated (in %) of Albania in 1998 to that in 2002?
Your response must be concise. 0.46. What is the ratio of the Revenue generated (in %) in Belarus in 1998 to that in 2002?
Keep it short and to the point. 0.96. What is the ratio of the Revenue generated (in %) in Bulgaria in 1998 to that in 2002?
Provide a short and direct response. 43.33. What is the ratio of the Revenue generated (in %) in Ireland in 1998 to that in 2002?
Provide a short and direct response. 0.95. What is the ratio of the Revenue generated (in %) in Albania in 1998 to that in 2003?
Ensure brevity in your answer.  0.2. What is the ratio of the Revenue generated (in %) in Belarus in 1998 to that in 2003?
Offer a terse response. 0.29. What is the ratio of the Revenue generated (in %) in Bulgaria in 1998 to that in 2003?
Offer a very short reply. 25.63. What is the ratio of the Revenue generated (in %) in Ireland in 1998 to that in 2003?
Offer a very short reply. 0.71. What is the ratio of the Revenue generated (in %) of Albania in 2002 to that in 2003?
Keep it short and to the point. 0.42. What is the ratio of the Revenue generated (in %) in Belarus in 2002 to that in 2003?
Give a very brief answer. 0.3. What is the ratio of the Revenue generated (in %) in Bulgaria in 2002 to that in 2003?
Make the answer very short. 0.59. What is the ratio of the Revenue generated (in %) of Ireland in 2002 to that in 2003?
Provide a succinct answer. 0.74. What is the difference between the highest and the second highest Revenue generated (in %) of Albania?
Ensure brevity in your answer.  1.36. What is the difference between the highest and the second highest Revenue generated (in %) of Belarus?
Give a very brief answer. 0.1. What is the difference between the highest and the second highest Revenue generated (in %) of Bulgaria?
Your answer should be very brief. 1.12. What is the difference between the highest and the second highest Revenue generated (in %) of Ireland?
Provide a short and direct response. 1.07. What is the difference between the highest and the lowest Revenue generated (in %) in Albania?
Ensure brevity in your answer.  2.28. What is the difference between the highest and the lowest Revenue generated (in %) of Belarus?
Your response must be concise. 7.94. What is the difference between the highest and the lowest Revenue generated (in %) of Bulgaria?
Offer a very short reply. 3.44. What is the difference between the highest and the lowest Revenue generated (in %) of Ireland?
Give a very brief answer. 1.98. 